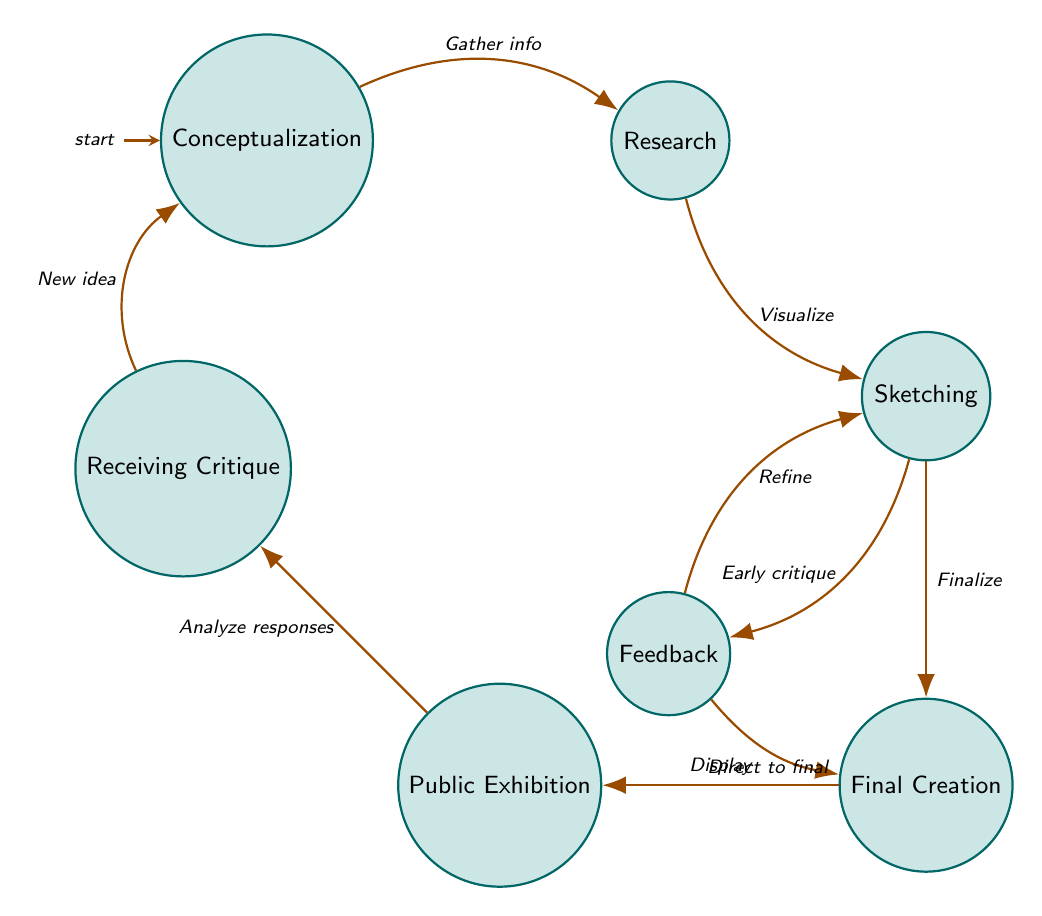What are the initial and final nodes in the diagram? The initial node is "Conceptualization" where the process begins. The final node is "Receiving Critique," which is where the process cycles back to the start.
Answer: Conceptualization, Receiving Critique How many nodes are present in the diagram? The diagram contains seven nodes, representing each stage of the creative process.
Answer: Seven What is the transition between Sketching and Final Creation? The transition from Sketching to Final Creation occurs when the artist decides to finalize their sketches into a completed piece.
Answer: Finalize Which node receives feedback before the Final Creation? The Feedback node receives critiques that inform the Sketching node and can direct the artist to final creation.
Answer: Feedback What action follows the Public Exhibition? The action that follows Public Exhibition is Receiving Critique, where the artist analyzes the responses from the audience and critics.
Answer: Receiving Critique Is there a transition from Research to Sketching? Yes, there is a direct transition from Research to Sketching, as the artist visualizes the ideas gathered during the research phase.
Answer: Yes What happens after Receiving Critique? After Receiving Critique, the process transitions back to Conceptualization where new ideas can stem from the critiques offered.
Answer: New idea Which node allows for refinement based on early critiques? The Feedback node allows for refinement, enabling the artist to improve their sketches based on critiques received from peers.
Answer: Feedback How many transitions lead from Sketching? There are three transitions that lead from Sketching: to Feedback, to Final Creation, and indirectly back to itself.
Answer: Three 